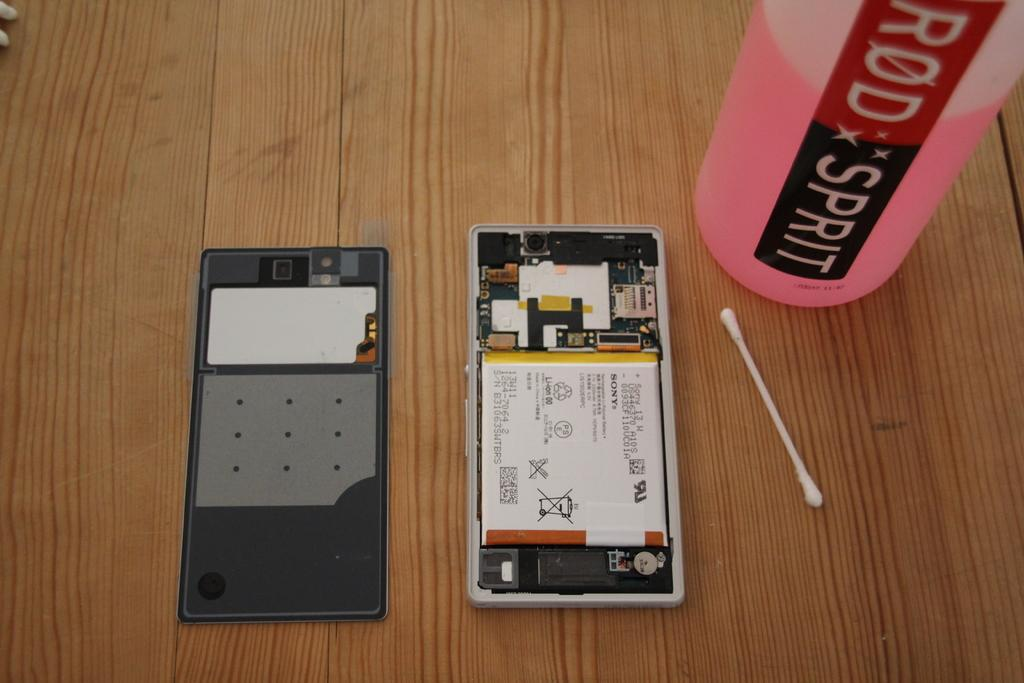<image>
Offer a succinct explanation of the picture presented. A phone with its back taken off is on a table next to a bottle that says Rod Sprit. 